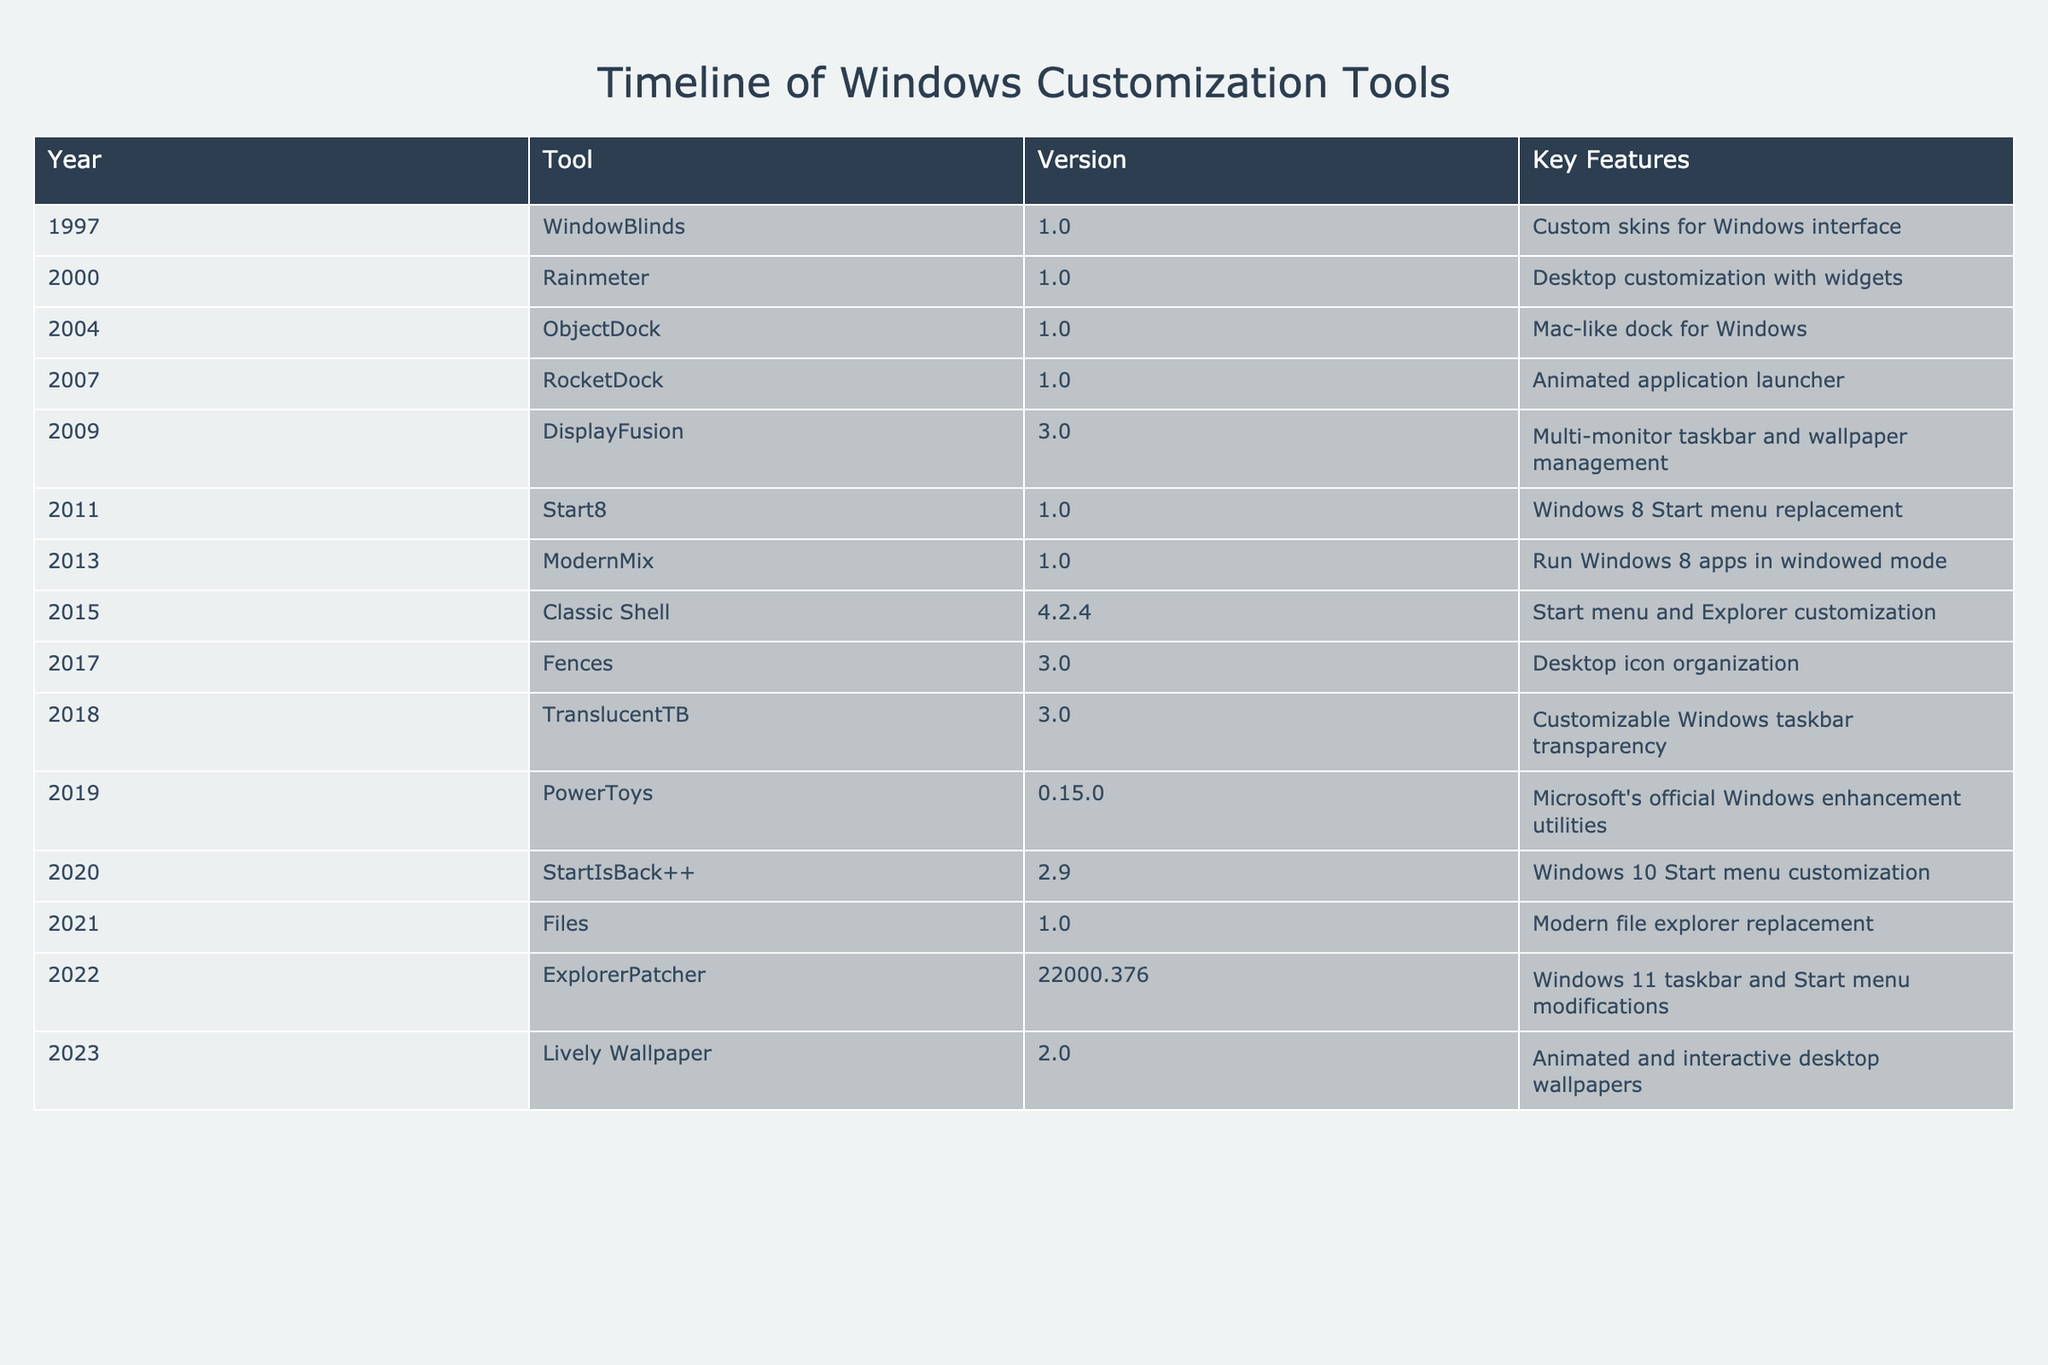What year was WindowBlinds first released? The table lists WindowBlinds under the year 1997 in the first row. Therefore, the first release year for WindowBlinds is clearly indicated as 1997.
Answer: 1997 Which tool was designed as a Windows 8 Start menu replacement? According to the table, the tool specifically created as a Windows 8 Start menu replacement is Start8, which is mentioned in the row for the year 2011.
Answer: Start8 What is the version of the tool DisplayFusion? The table shows DisplayFusion in the row corresponding to the year 2009, with the version listed as 3.0.
Answer: 3.0 How many tools were released after 2015? To determine this, consider the tools released from 2016 onward: Fences (2017), TranslucentTB (2018), PowerToys (2019), StartIsBack++ (2020), Files (2021), ExplorerPatcher (2022), and Lively Wallpaper (2023). This gives us a total of 7 tools released after 2015.
Answer: 7 Is there a tool in the table that offers desktop wallpaper management? Looking at the table, DisplayFusion (year 2009) is noted for its multi-monitor taskbar and wallpaper management, confirming that there is indeed a tool that fits this description.
Answer: Yes Which tool provides customizable taskbar transparency and what version is it? The table lists TranslucentTB as the tool providing customizable Windows taskbar transparency, with the version noted as 3.0 in the year 2018.
Answer: TranslucentTB, version 3.0 What was the earliest version of Rainmeter? Referring to the row for Rainmeter in the year 2000, it shows the earliest version as 1.0.
Answer: 1.0 How many tools were released in the year 2010 or earlier? From the table, we can identify the following tools released in 2010 or earlier: WindowBlinds (1997), Rainmeter (2000), ObjectDock (2004), RocketDock (2007), and DisplayFusion (2009). This sums up to 5 tools released in that time frame.
Answer: 5 What is the most recent version mentioned in the table? The table shows Lively Wallpaper released in 2023 with version 2.0, making it the most recent version entry in the dataset.
Answer: 2.0 